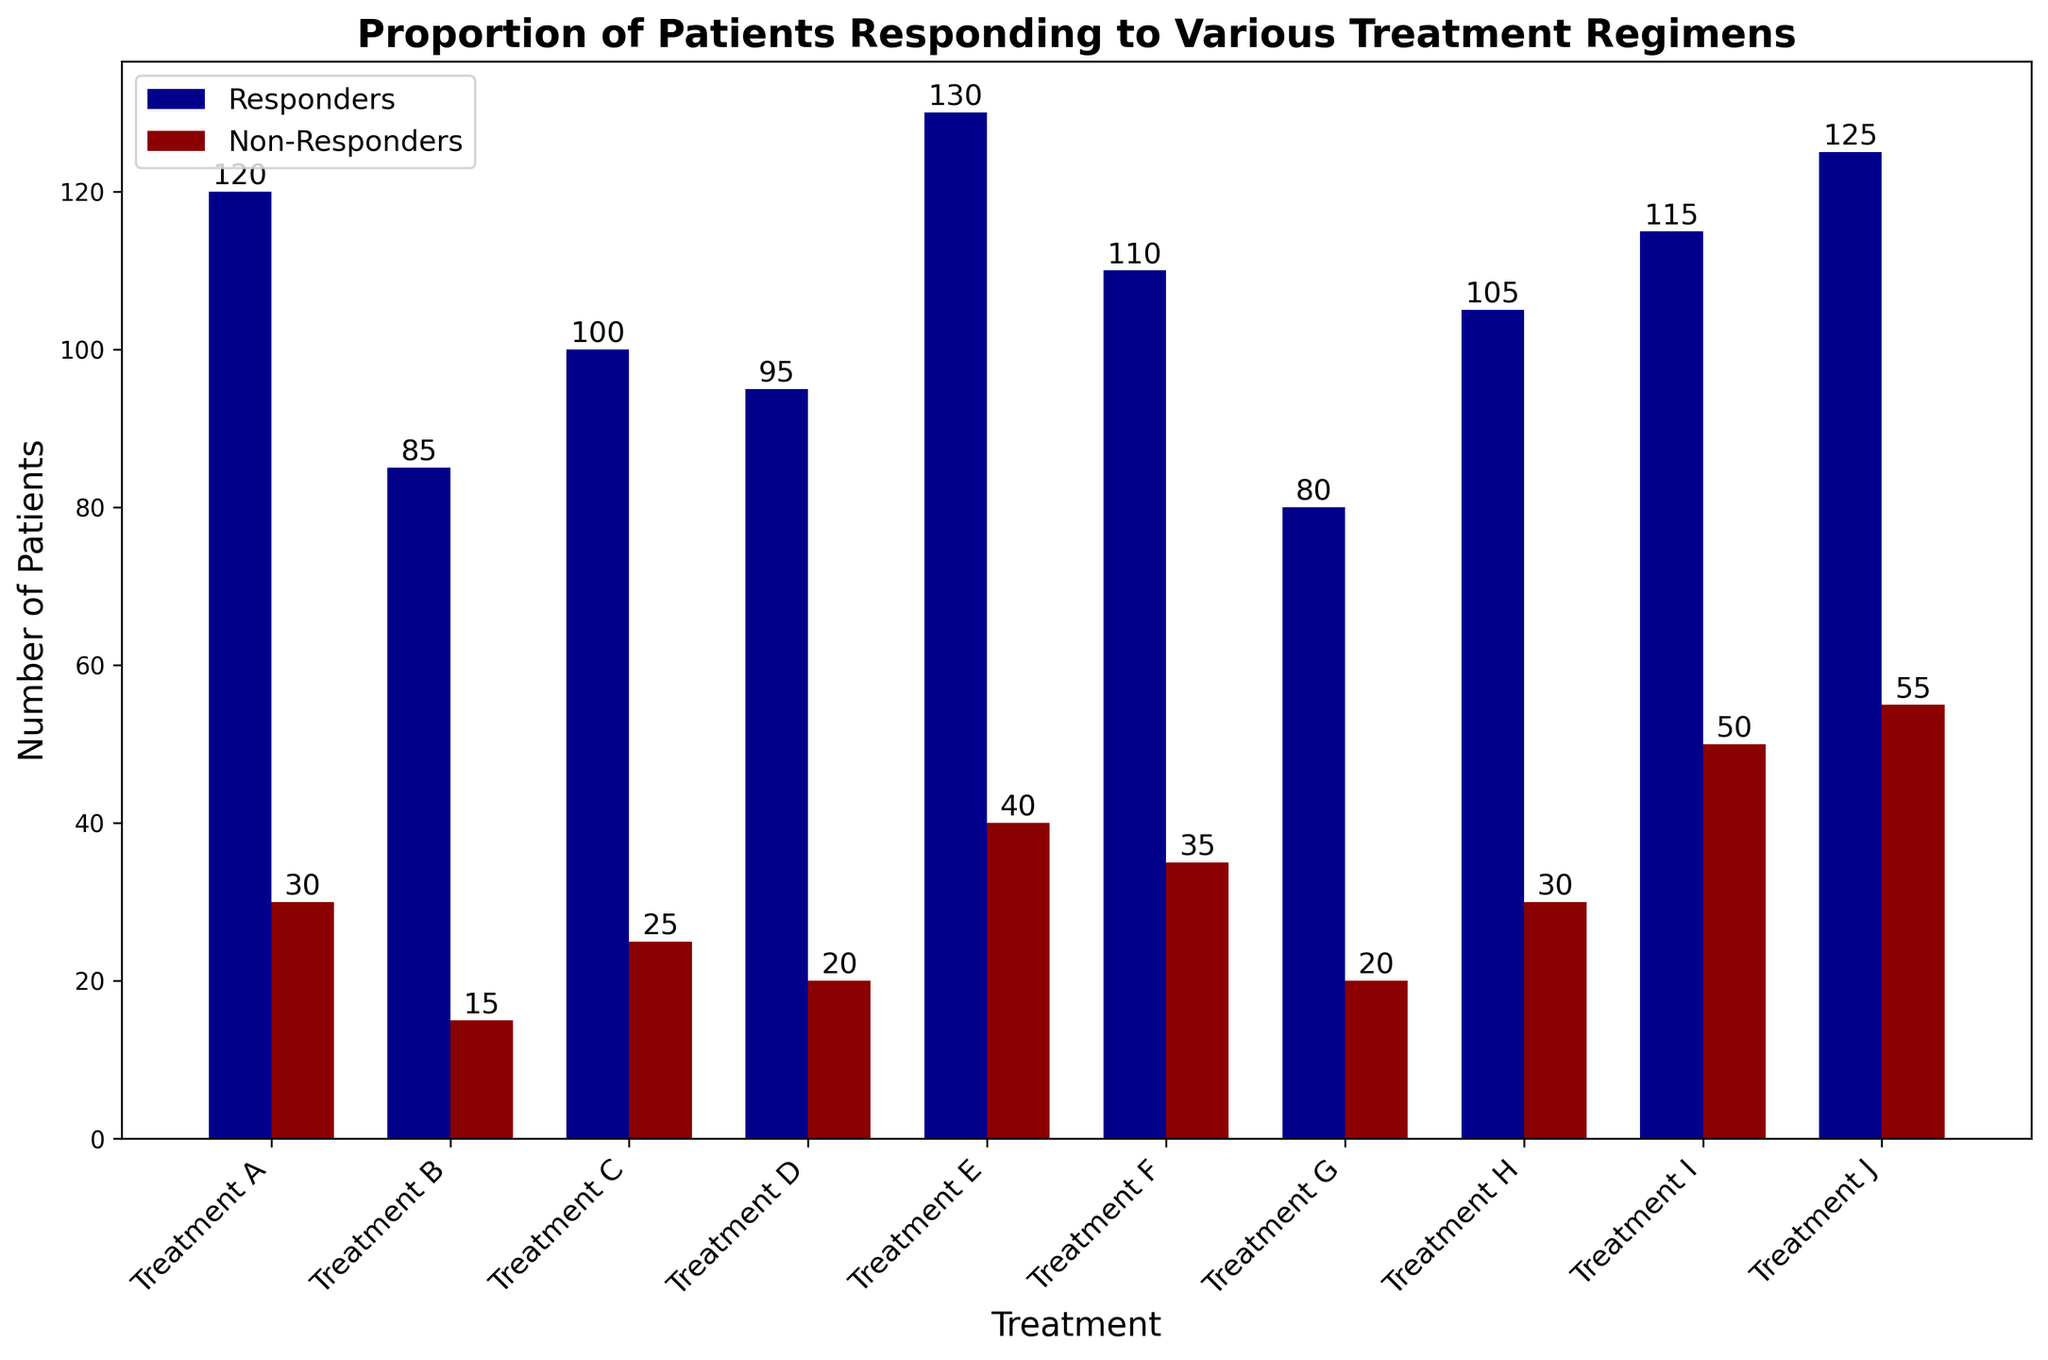What treatment had the highest number of responders? Check the height of the bars representing responders for each treatment. Count and verify Treatment E has the tallest bar in the responder category.
Answer: Treatment E How many more responders did Treatment A have compared to Treatment B? Subtract the number of responders in Treatment B from the number of responders in Treatment A: 120 - 85
Answer: 35 What’s the difference in the number of total patients (responders + non-responders) between Treatment I and Treatment J? Calculate the total patients for Treatment I (115 + 50 = 165) and Treatment J (125 + 55 = 180). Subtract the total patients of Treatment I from Treatment J: 180 - 165
Answer: 15 Which treatments had equal numbers of non-responders? Check the heights of the bars representing non-responders. Treatment D and Treatment G both have 20 non-responders.
Answer: Treatment D, Treatment G What is the average number of responders across all treatments? Sum up the number of responders: 120 + 85 + 100 + 95 + 130 + 110 + 80 + 105 + 115 + 125 = 1065. Divide by the number of treatments: 1065 / 10
Answer: 106.5 Is the number of non-responders higher in Treatment F or Treatment H? Compare the heights of non-responder bars. Treatment F has 35 non-responders, and Treatment H has 30 non-responders.
Answer: Treatment F What’s the combined total of non-responders for Treatments A, B, and C? Add the number of non-responders for Treatments A, B, and C: 30 + 15 + 25
Answer: 70 Which color represents the non-responders in the bar chart? Identify the color of the bars labeled non-responders. The bars labeled non-responders are dark red.
Answer: Dark red 